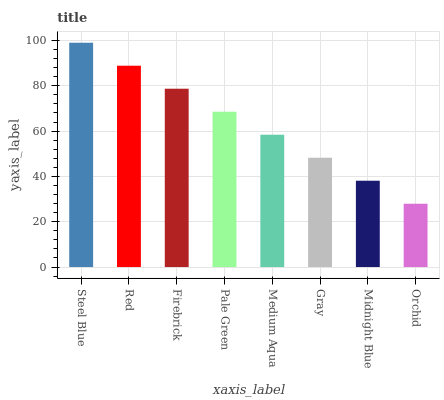Is Orchid the minimum?
Answer yes or no. Yes. Is Steel Blue the maximum?
Answer yes or no. Yes. Is Red the minimum?
Answer yes or no. No. Is Red the maximum?
Answer yes or no. No. Is Steel Blue greater than Red?
Answer yes or no. Yes. Is Red less than Steel Blue?
Answer yes or no. Yes. Is Red greater than Steel Blue?
Answer yes or no. No. Is Steel Blue less than Red?
Answer yes or no. No. Is Pale Green the high median?
Answer yes or no. Yes. Is Medium Aqua the low median?
Answer yes or no. Yes. Is Firebrick the high median?
Answer yes or no. No. Is Red the low median?
Answer yes or no. No. 